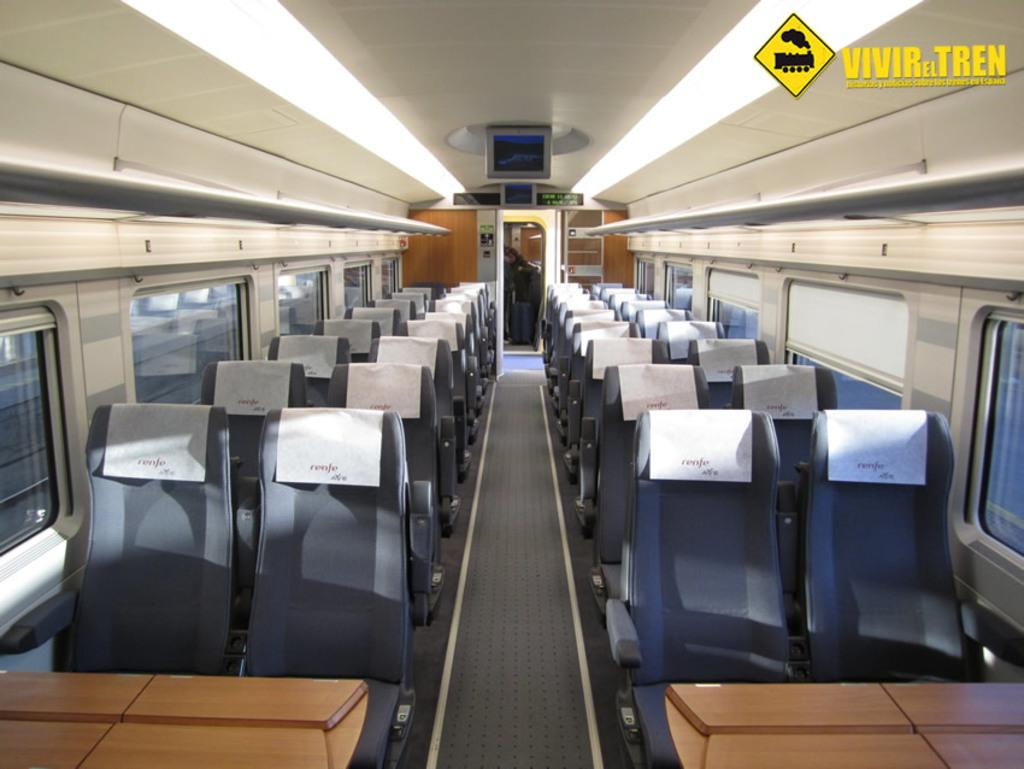What type of space is depicted in the image? The image shows an interior view of a vehicle. What furniture is present in the vehicle? There are seats and tables in the vehicle. What type of display is visible in the vehicle? There is a screen on the top of the vehicle. Is there anyone inside the vehicle? Yes, a person is present in the vehicle. What type of button does the person's uncle press to activate the screen in the image? There is no uncle or button present in the image, and therefore no such interaction can be observed. 